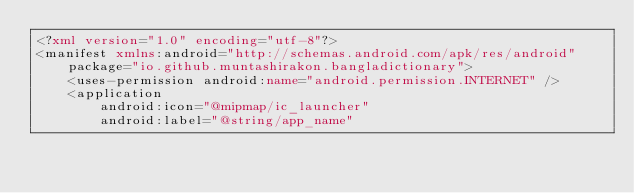<code> <loc_0><loc_0><loc_500><loc_500><_XML_><?xml version="1.0" encoding="utf-8"?>
<manifest xmlns:android="http://schemas.android.com/apk/res/android"
    package="io.github.muntashirakon.bangladictionary">
    <uses-permission android:name="android.permission.INTERNET" />
    <application
        android:icon="@mipmap/ic_launcher"
        android:label="@string/app_name"</code> 